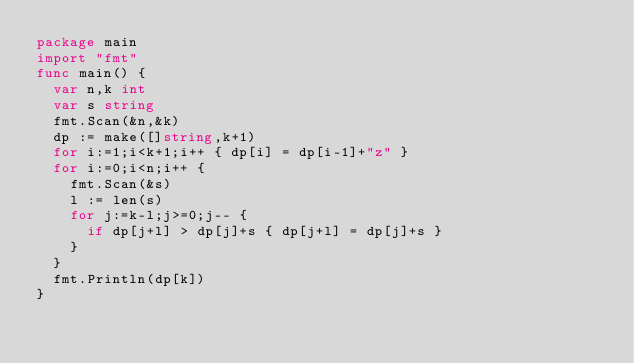Convert code to text. <code><loc_0><loc_0><loc_500><loc_500><_Go_>package main
import "fmt"
func main() {
  var n,k int
  var s string
  fmt.Scan(&n,&k)
  dp := make([]string,k+1)
  for i:=1;i<k+1;i++ { dp[i] = dp[i-1]+"z" }
  for i:=0;i<n;i++ {
    fmt.Scan(&s)
    l := len(s)
    for j:=k-l;j>=0;j-- {
      if dp[j+l] > dp[j]+s { dp[j+l] = dp[j]+s }
    }
  }
  fmt.Println(dp[k])
}</code> 